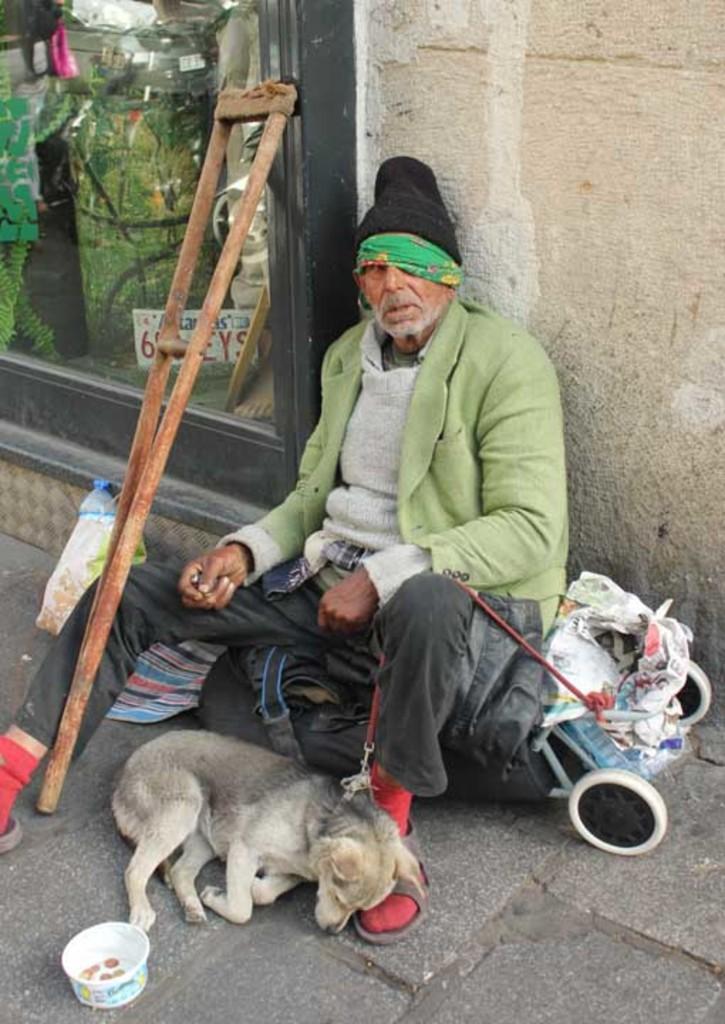Can you describe this image briefly? In this image I see a man and there is a dog near him and they are on the path. I can also see a bowl, a stick and the wall. 